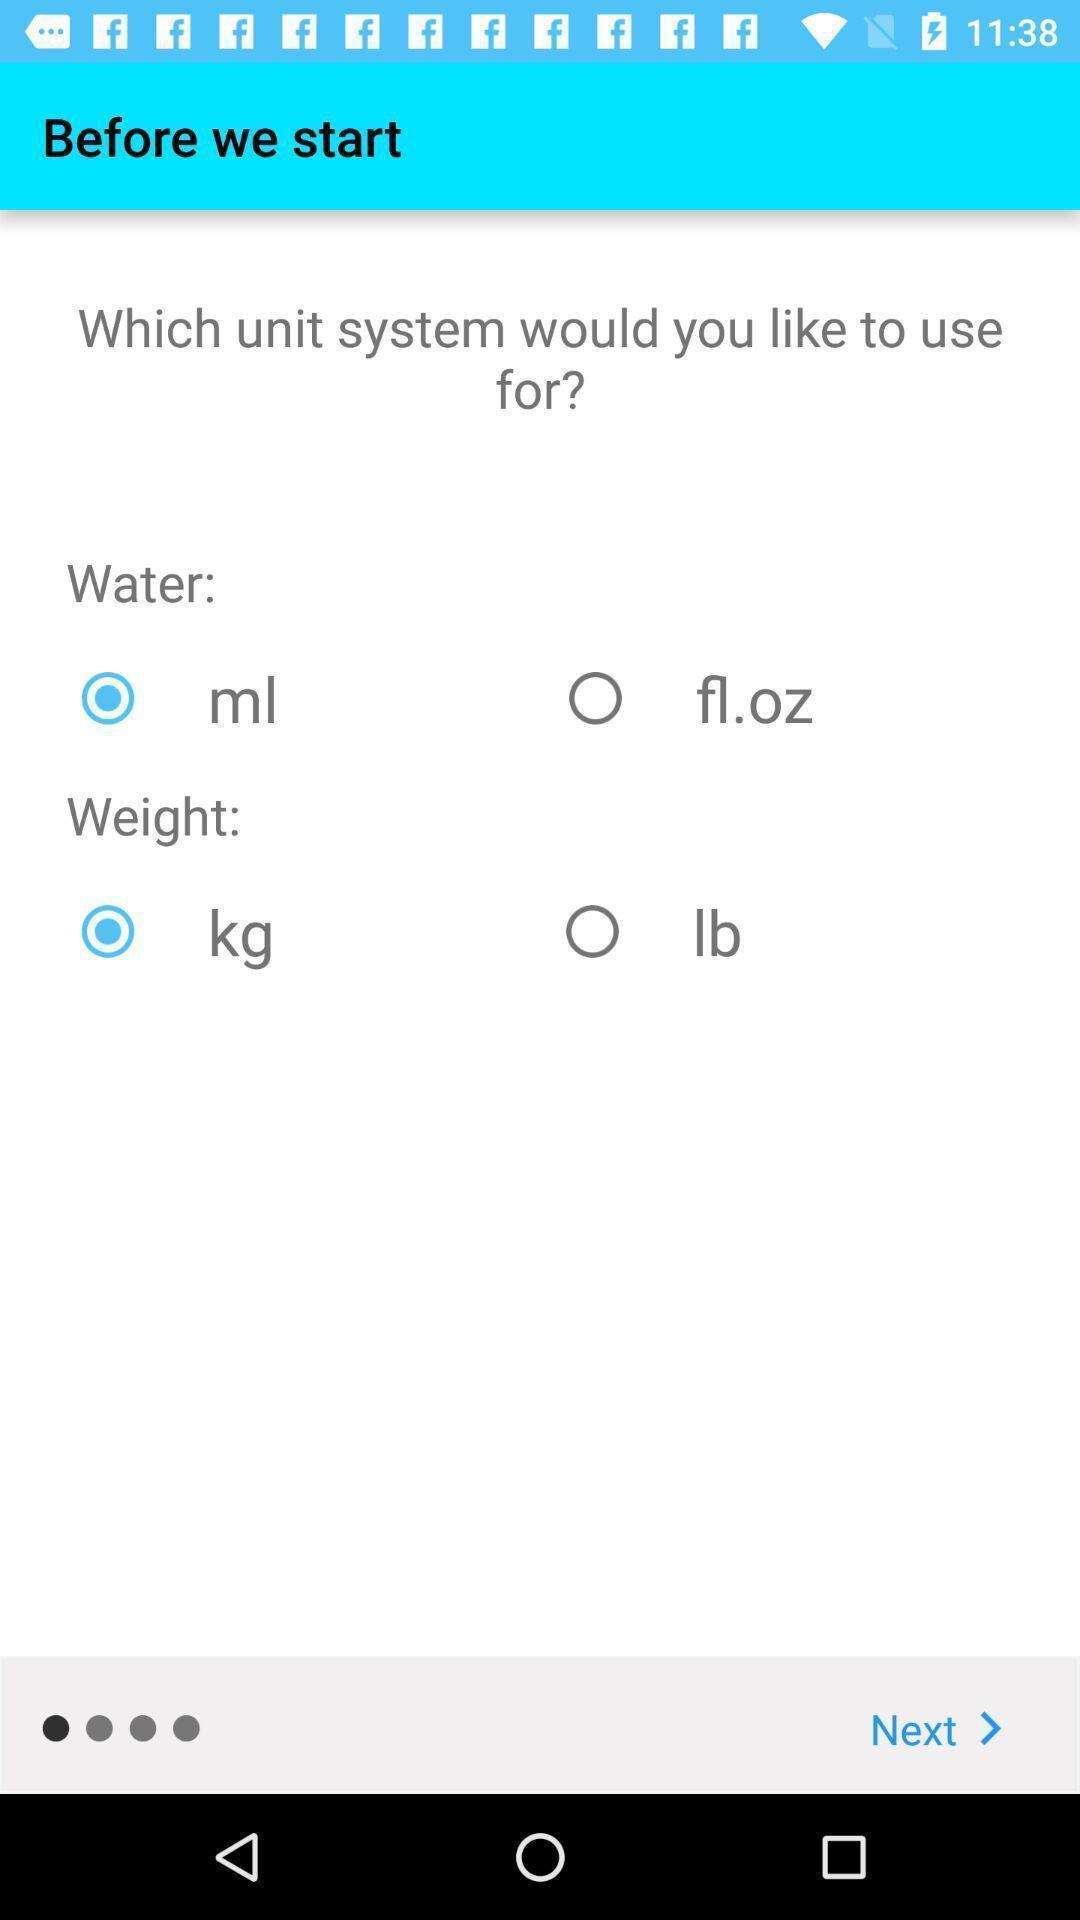Tell me what you see in this picture. Screen showing units for water and weight. 